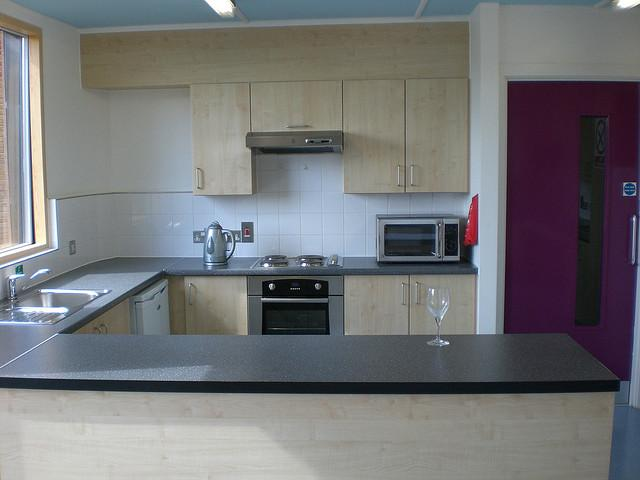What is on top of the counter? Please explain your reasoning. coffee pot. It is easily visible and recognizable by it's shape and that it has a handle for pouring hot liquids without burning yourself. 